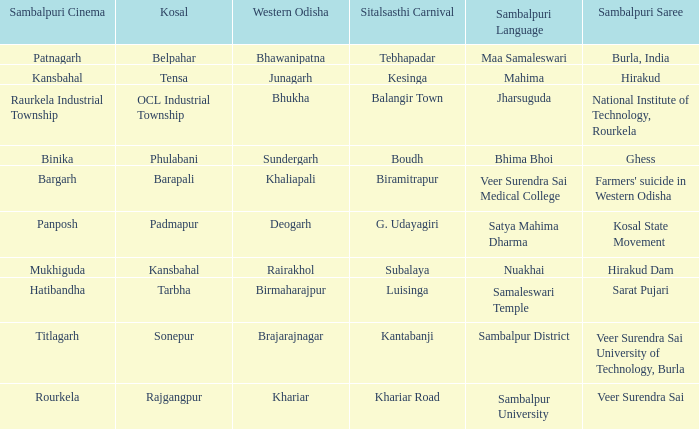Parse the full table. {'header': ['Sambalpuri Cinema', 'Kosal', 'Western Odisha', 'Sitalsasthi Carnival', 'Sambalpuri Language', 'Sambalpuri Saree'], 'rows': [['Patnagarh', 'Belpahar', 'Bhawanipatna', 'Tebhapadar', 'Maa Samaleswari', 'Burla, India'], ['Kansbahal', 'Tensa', 'Junagarh', 'Kesinga', 'Mahima', 'Hirakud'], ['Raurkela Industrial Township', 'OCL Industrial Township', 'Bhukha', 'Balangir Town', 'Jharsuguda', 'National Institute of Technology, Rourkela'], ['Binika', 'Phulabani', 'Sundergarh', 'Boudh', 'Bhima Bhoi', 'Ghess'], ['Bargarh', 'Barapali', 'Khaliapali', 'Biramitrapur', 'Veer Surendra Sai Medical College', "Farmers' suicide in Western Odisha"], ['Panposh', 'Padmapur', 'Deogarh', 'G. Udayagiri', 'Satya Mahima Dharma', 'Kosal State Movement'], ['Mukhiguda', 'Kansbahal', 'Rairakhol', 'Subalaya', 'Nuakhai', 'Hirakud Dam'], ['Hatibandha', 'Tarbha', 'Birmaharajpur', 'Luisinga', 'Samaleswari Temple', 'Sarat Pujari'], ['Titlagarh', 'Sonepur', 'Brajarajnagar', 'Kantabanji', 'Sambalpur District', 'Veer Surendra Sai University of Technology, Burla'], ['Rourkela', 'Rajgangpur', 'Khariar', 'Khariar Road', 'Sambalpur University', 'Veer Surendra Sai']]} What is the Kosal with a balangir town sitalsasthi carnival? OCL Industrial Township. 